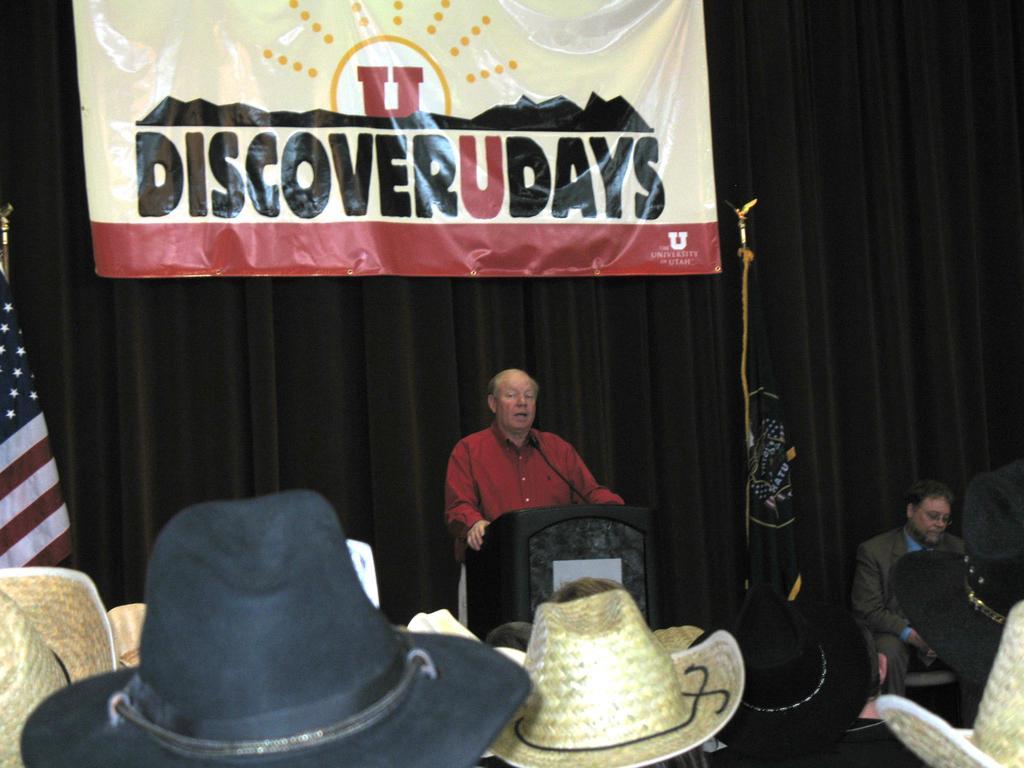How would you summarize this image in a sentence or two? In this image there is a person standing on the dais is speaking in front of the mic, beside the person there are flags and there is a person sitting in a chair, behind the person there is a banner on the curtain, in front of the person there are a few people wearing hats. 